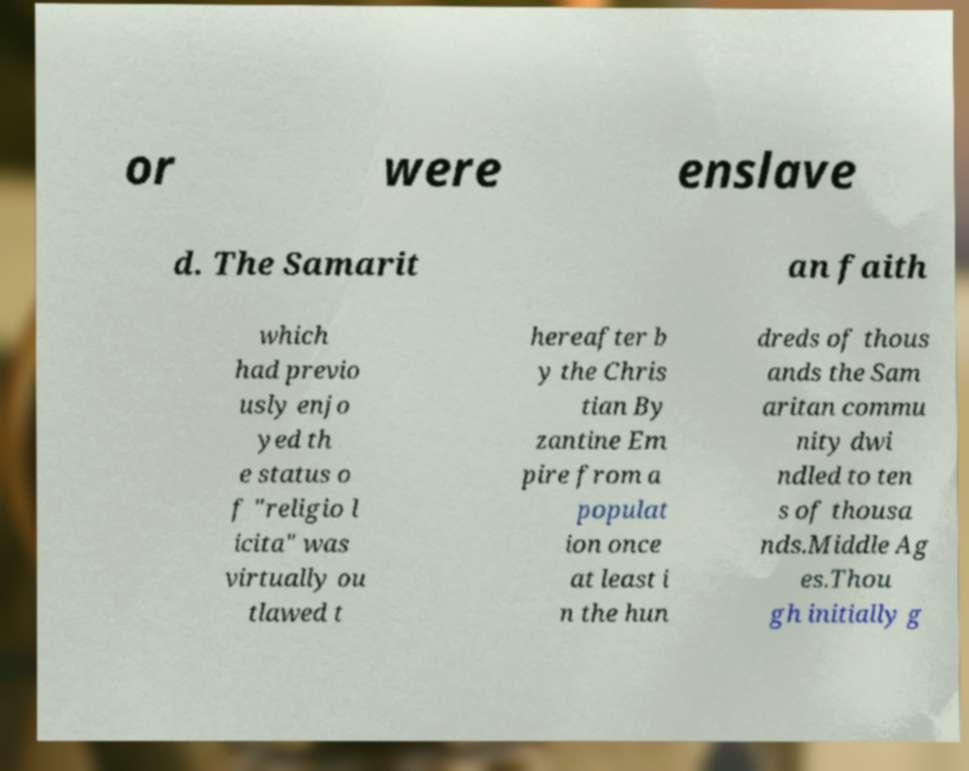Can you accurately transcribe the text from the provided image for me? or were enslave d. The Samarit an faith which had previo usly enjo yed th e status o f "religio l icita" was virtually ou tlawed t hereafter b y the Chris tian By zantine Em pire from a populat ion once at least i n the hun dreds of thous ands the Sam aritan commu nity dwi ndled to ten s of thousa nds.Middle Ag es.Thou gh initially g 